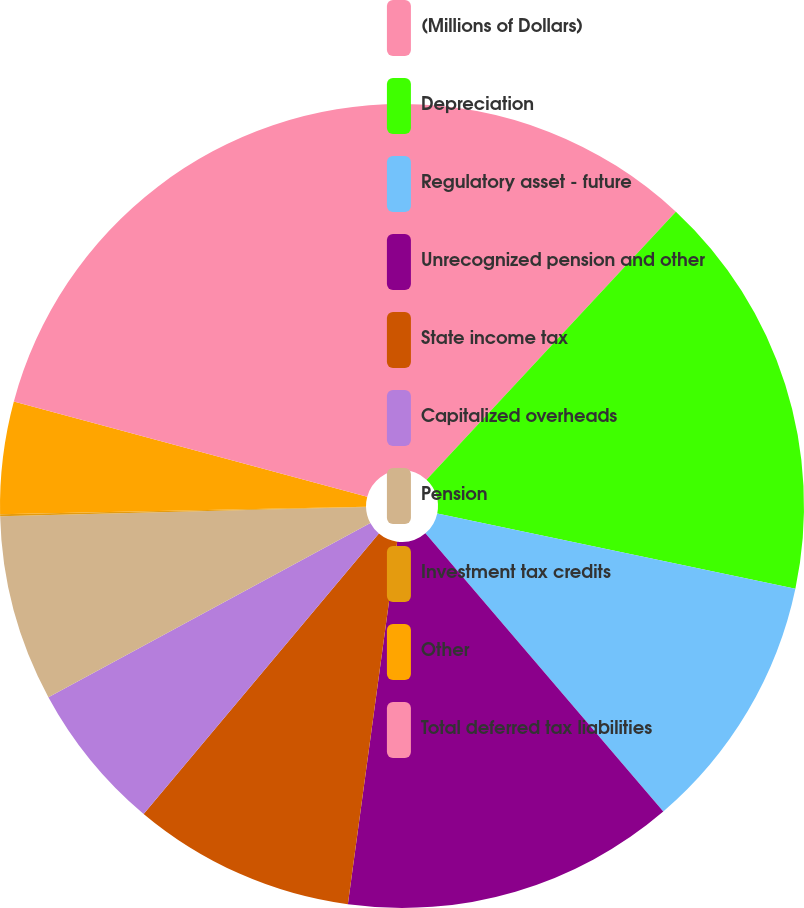Convert chart. <chart><loc_0><loc_0><loc_500><loc_500><pie_chart><fcel>(Millions of Dollars)<fcel>Depreciation<fcel>Regulatory asset - future<fcel>Unrecognized pension and other<fcel>State income tax<fcel>Capitalized overheads<fcel>Pension<fcel>Investment tax credits<fcel>Other<fcel>Total deferred tax liabilities<nl><fcel>11.93%<fcel>16.37%<fcel>10.44%<fcel>13.41%<fcel>8.96%<fcel>6.0%<fcel>7.48%<fcel>0.08%<fcel>4.52%<fcel>20.81%<nl></chart> 